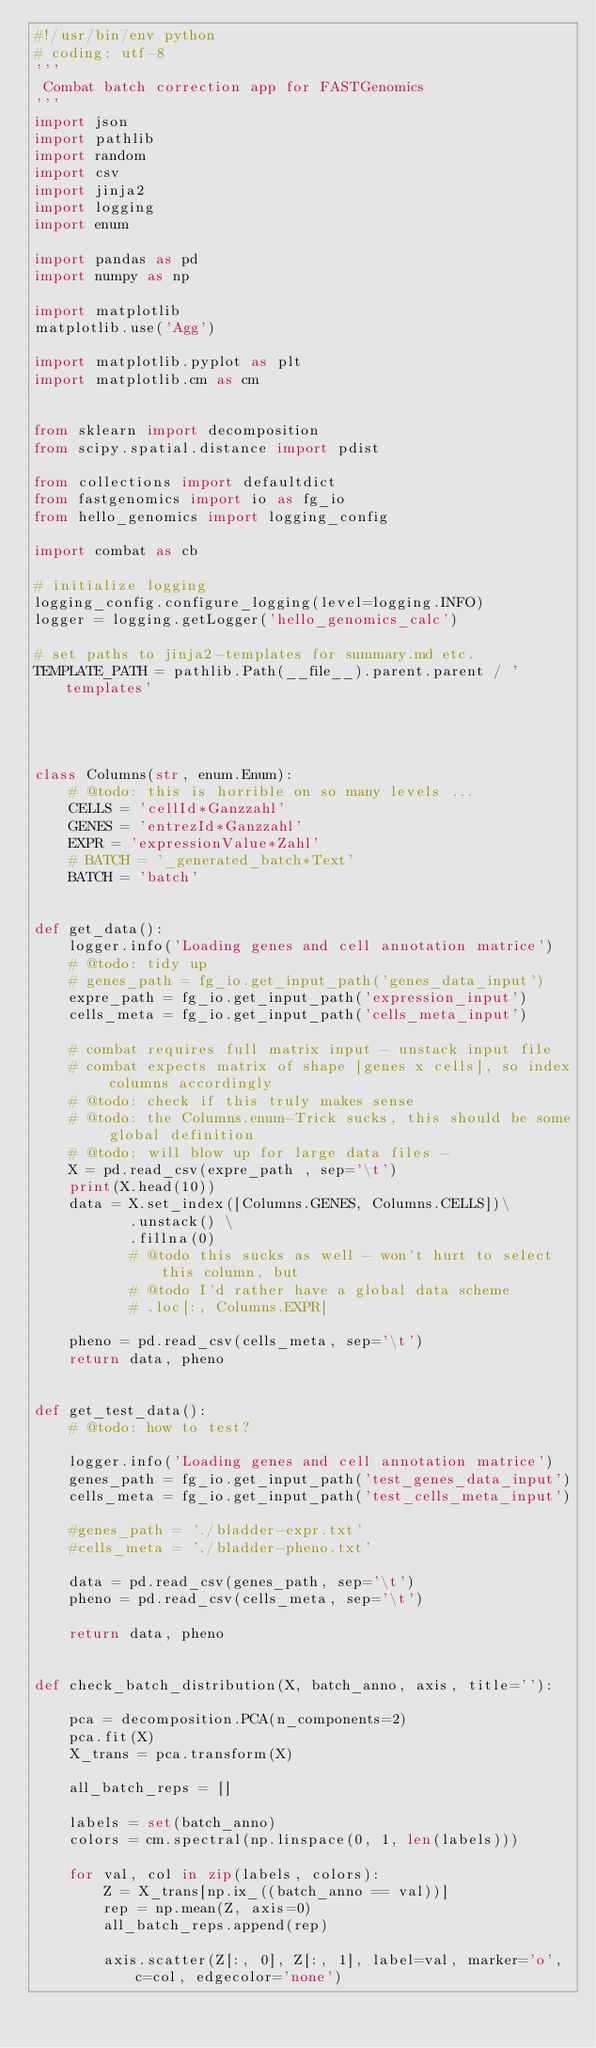<code> <loc_0><loc_0><loc_500><loc_500><_Python_>#!/usr/bin/env python
# coding: utf-8
'''
 Combat batch correction app for FASTGenomics
'''
import json
import pathlib
import random
import csv
import jinja2
import logging
import enum

import pandas as pd
import numpy as np

import matplotlib
matplotlib.use('Agg')

import matplotlib.pyplot as plt
import matplotlib.cm as cm


from sklearn import decomposition
from scipy.spatial.distance import pdist

from collections import defaultdict
from fastgenomics import io as fg_io
from hello_genomics import logging_config

import combat as cb

# initialize logging
logging_config.configure_logging(level=logging.INFO)
logger = logging.getLogger('hello_genomics_calc')

# set paths to jinja2-templates for summary.md etc.
TEMPLATE_PATH = pathlib.Path(__file__).parent.parent / 'templates'




class Columns(str, enum.Enum):
    # @todo: this is horrible on so many levels ...
    CELLS = 'cellId*Ganzzahl'
    GENES = 'entrezId*Ganzzahl'
    EXPR = 'expressionValue*Zahl'
    # BATCH = '_generated_batch*Text'
    BATCH = 'batch'


def get_data():
    logger.info('Loading genes and cell annotation matrice')
    # @todo: tidy up
    # genes_path = fg_io.get_input_path('genes_data_input')
    expre_path = fg_io.get_input_path('expression_input')
    cells_meta = fg_io.get_input_path('cells_meta_input')

    # combat requires full matrix input - unstack input file
    # combat expects matrix of shape [genes x cells], so index columns accordingly
    # @todo: check if this truly makes sense
    # @todo: the Columns.enum-Trick sucks, this should be some global definition
    # @todo: will blow up for large data files - 
    X = pd.read_csv(expre_path , sep='\t')
    print(X.head(10))
    data = X.set_index([Columns.GENES, Columns.CELLS])\
           .unstack() \
           .fillna(0)
           # @todo this sucks as well - won't hurt to select this column, but
           # @todo I'd rather have a global data scheme
           # .loc[:, Columns.EXPR]

    pheno = pd.read_csv(cells_meta, sep='\t')
    return data, pheno


def get_test_data():
    # @todo: how to test?
    
    logger.info('Loading genes and cell annotation matrice')
    genes_path = fg_io.get_input_path('test_genes_data_input')
    cells_meta = fg_io.get_input_path('test_cells_meta_input')

    #genes_path = './bladder-expr.txt'
    #cells_meta = './bladder-pheno.txt'
    
    data = pd.read_csv(genes_path, sep='\t')
    pheno = pd.read_csv(cells_meta, sep='\t')

    return data, pheno


def check_batch_distribution(X, batch_anno, axis, title=''):
    
    pca = decomposition.PCA(n_components=2)
    pca.fit(X)
    X_trans = pca.transform(X)

    all_batch_reps = []

    labels = set(batch_anno)
    colors = cm.spectral(np.linspace(0, 1, len(labels)))

    for val, col in zip(labels, colors):
        Z = X_trans[np.ix_((batch_anno == val))]
        rep = np.mean(Z, axis=0)
        all_batch_reps.append(rep)

        axis.scatter(Z[:, 0], Z[:, 1], label=val, marker='o', c=col, edgecolor='none')</code> 